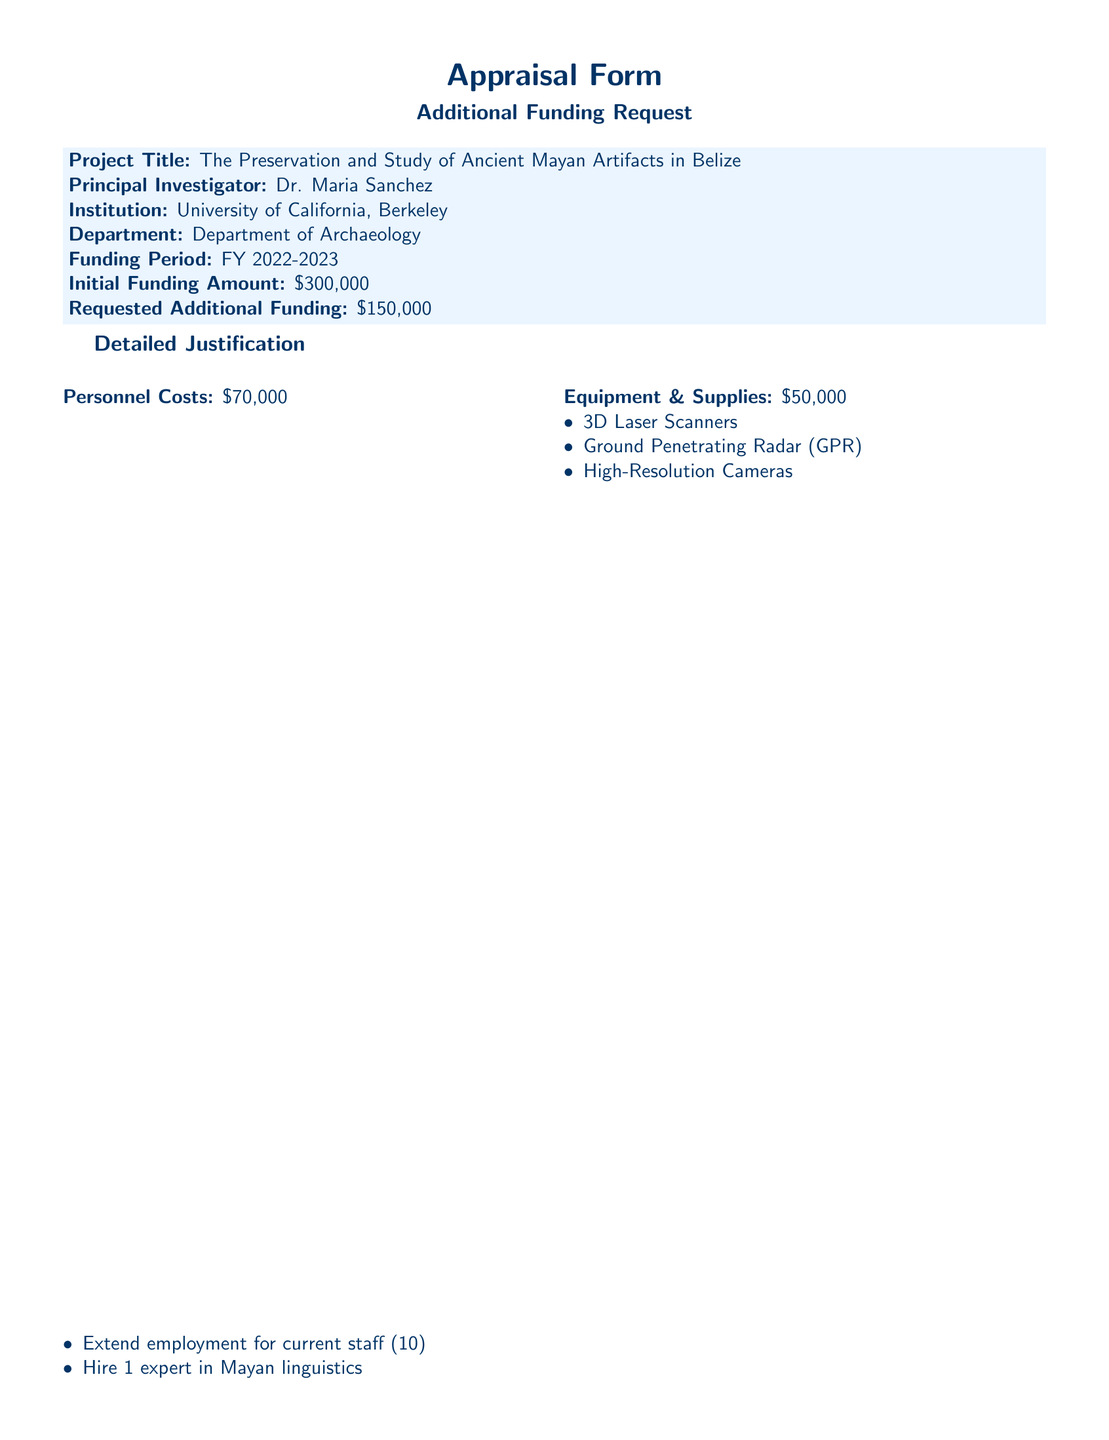What is the project title? The project title is explicitly stated in the document under project details.
Answer: The Preservation and Study of Ancient Mayan Artifacts in Belize Who is the principal investigator? The principal investigator is identified in the document.
Answer: Dr. Maria Sanchez What is the total amount of requested additional funding? The total requested additional funding is mentioned in the funding details section.
Answer: $150,000 How many trips are planned between California and Belize? The number of planned trips is outlined under travel expenses in the document.
Answer: 5 What portion of the additional funding is allocated for personnel costs? The specific portion for personnel costs is clearly stated in the detailed justification section.
Answer: $70,000 What is one of the short-term benefits mentioned in the document? The short-term benefits are listed in the funding impact section, emphasizing immediate outcomes.
Answer: More significant insights into Mayan civilization What compliance costs are included in the request? The specific compliance costs are broken down in the detailed justification.
Answer: Legal counsel and permits What is the initial funding amount provided for the project? The initial funding amount is specified clearly in the document.
Answer: $300,000 Which institution is Dr. Maria Sanchez affiliated with? The institution is mentioned in the project details at the beginning of the document.
Answer: University of California, Berkeley 